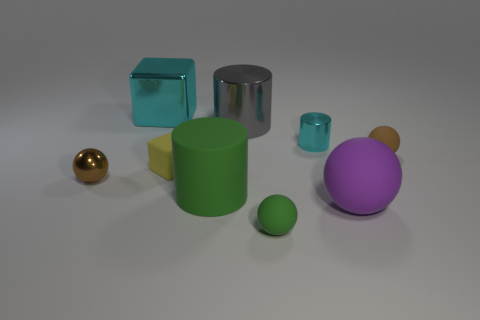There is a cylinder that is the same color as the big shiny block; what size is it?
Make the answer very short. Small. There is a tiny green object left of the cyan shiny object that is in front of the large shiny cube; what is it made of?
Offer a terse response. Rubber. What number of objects are either purple matte balls or small things to the left of the large gray metal cylinder?
Offer a terse response. 3. What size is the cyan cylinder that is the same material as the big cyan block?
Your answer should be very brief. Small. How many brown objects are tiny rubber balls or large balls?
Give a very brief answer. 1. The large shiny object that is the same color as the tiny metallic cylinder is what shape?
Provide a succinct answer. Cube. Are there any other things that are the same material as the yellow cube?
Provide a short and direct response. Yes. There is a brown object that is to the left of the small cyan metallic object; is it the same shape as the small metal thing right of the tiny brown metallic object?
Your response must be concise. No. How many small cyan metallic cylinders are there?
Give a very brief answer. 1. There is a cyan object that is made of the same material as the cyan cylinder; what shape is it?
Provide a succinct answer. Cube. 